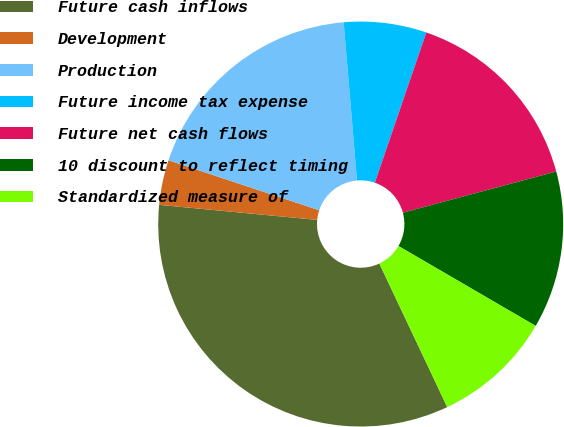Convert chart to OTSL. <chart><loc_0><loc_0><loc_500><loc_500><pie_chart><fcel>Future cash inflows<fcel>Development<fcel>Production<fcel>Future income tax expense<fcel>Future net cash flows<fcel>10 discount to reflect timing<fcel>Standardized measure of<nl><fcel>33.54%<fcel>3.59%<fcel>18.56%<fcel>6.59%<fcel>15.57%<fcel>12.57%<fcel>9.58%<nl></chart> 